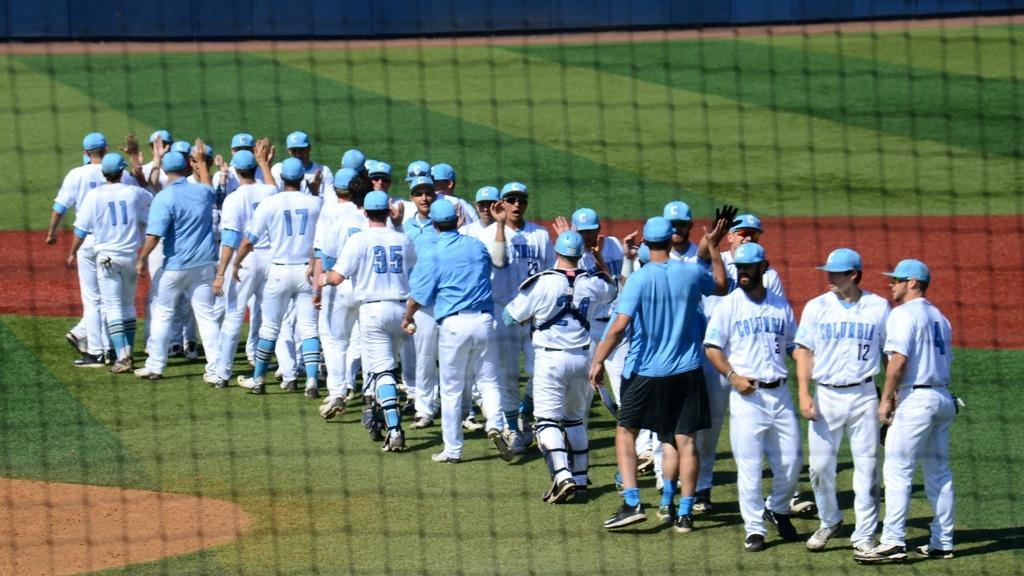<image>
Write a terse but informative summary of the picture. Baseball players greeting with each other including a catcher with number 24. 